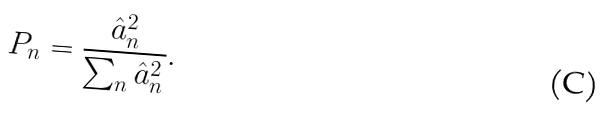<formula> <loc_0><loc_0><loc_500><loc_500>P _ { n } = \frac { \hat { a } ^ { 2 } _ { n } } { \sum _ { n } \hat { a } _ { n } ^ { 2 } } .</formula> 